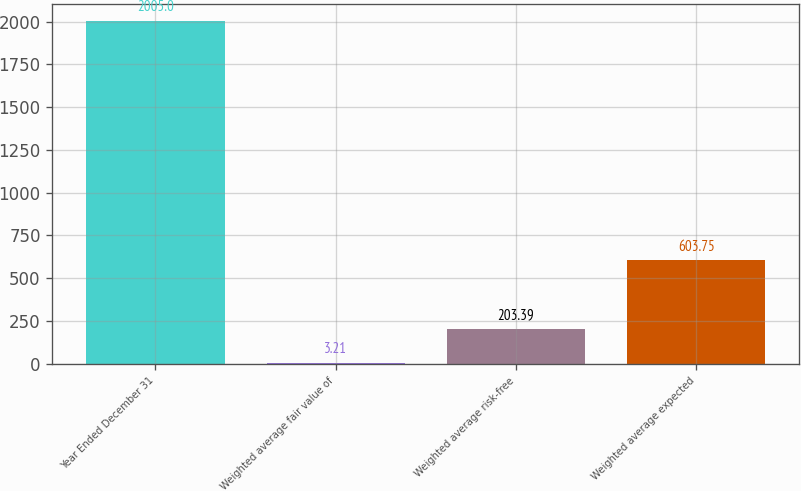<chart> <loc_0><loc_0><loc_500><loc_500><bar_chart><fcel>Year Ended December 31<fcel>Weighted average fair value of<fcel>Weighted average risk-free<fcel>Weighted average expected<nl><fcel>2005<fcel>3.21<fcel>203.39<fcel>603.75<nl></chart> 